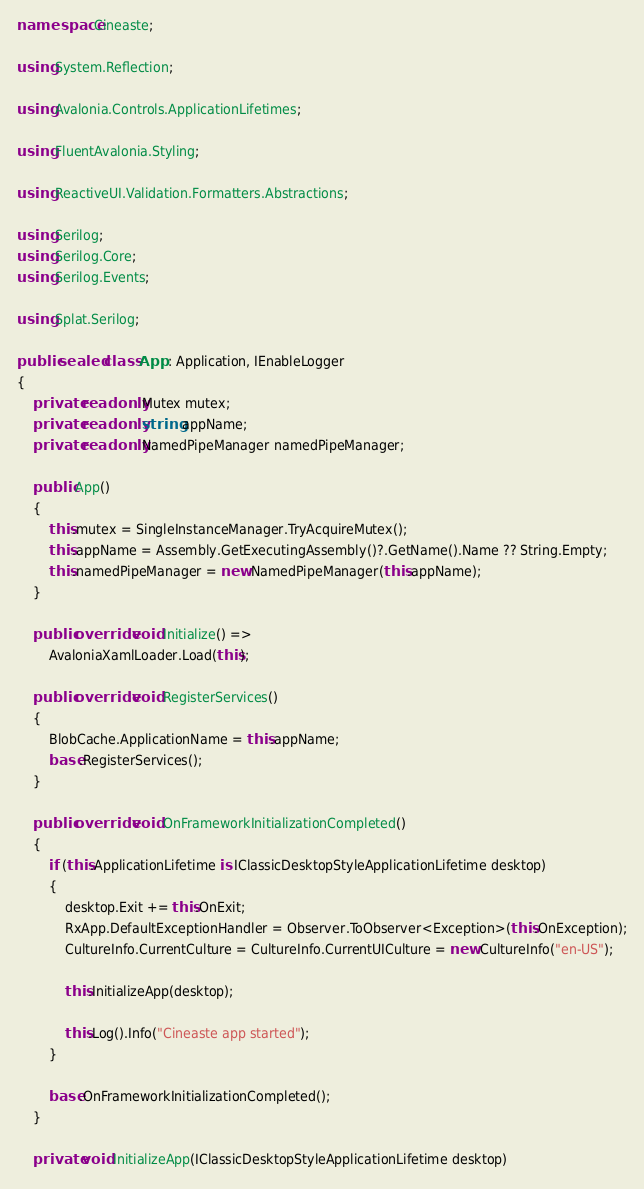<code> <loc_0><loc_0><loc_500><loc_500><_C#_>namespace Cineaste;

using System.Reflection;

using Avalonia.Controls.ApplicationLifetimes;

using FluentAvalonia.Styling;

using ReactiveUI.Validation.Formatters.Abstractions;

using Serilog;
using Serilog.Core;
using Serilog.Events;

using Splat.Serilog;

public sealed class App : Application, IEnableLogger
{
    private readonly Mutex mutex;
    private readonly string appName;
    private readonly NamedPipeManager namedPipeManager;

    public App()
    {
        this.mutex = SingleInstanceManager.TryAcquireMutex();
        this.appName = Assembly.GetExecutingAssembly()?.GetName().Name ?? String.Empty;
        this.namedPipeManager = new NamedPipeManager(this.appName);
    }

    public override void Initialize() =>
        AvaloniaXamlLoader.Load(this);

    public override void RegisterServices()
    {
        BlobCache.ApplicationName = this.appName;
        base.RegisterServices();
    }

    public override void OnFrameworkInitializationCompleted()
    {
        if (this.ApplicationLifetime is IClassicDesktopStyleApplicationLifetime desktop)
        {
            desktop.Exit += this.OnExit;
            RxApp.DefaultExceptionHandler = Observer.ToObserver<Exception>(this.OnException);
            CultureInfo.CurrentCulture = CultureInfo.CurrentUICulture = new CultureInfo("en-US");

            this.InitializeApp(desktop);

            this.Log().Info("Cineaste app started");
        }

        base.OnFrameworkInitializationCompleted();
    }

    private void InitializeApp(IClassicDesktopStyleApplicationLifetime desktop)</code> 